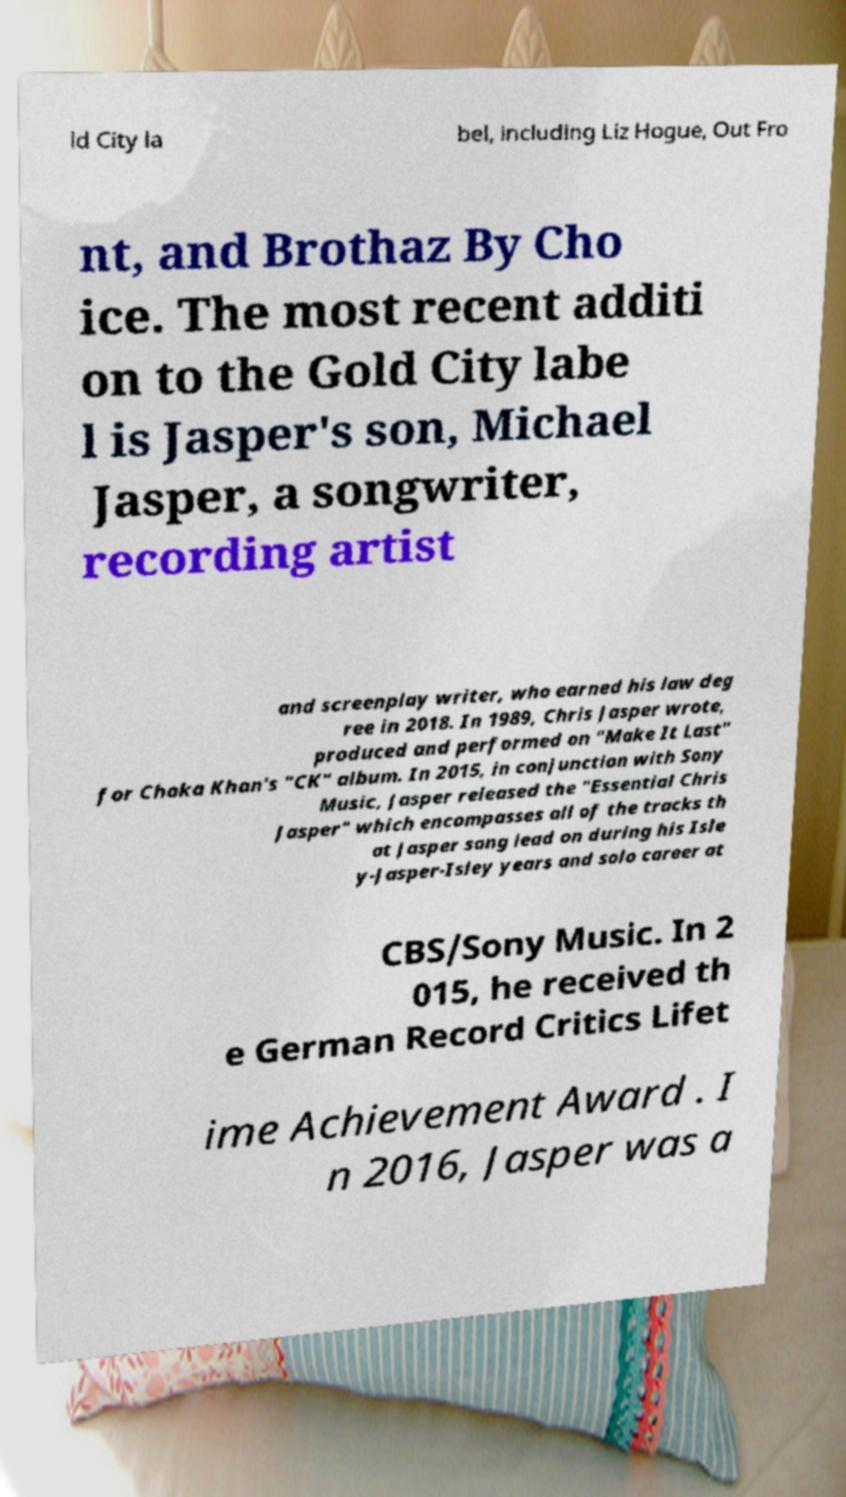Can you read and provide the text displayed in the image?This photo seems to have some interesting text. Can you extract and type it out for me? ld City la bel, including Liz Hogue, Out Fro nt, and Brothaz By Cho ice. The most recent additi on to the Gold City labe l is Jasper's son, Michael Jasper, a songwriter, recording artist and screenplay writer, who earned his law deg ree in 2018. In 1989, Chris Jasper wrote, produced and performed on "Make It Last" for Chaka Khan's "CK" album. In 2015, in conjunction with Sony Music, Jasper released the "Essential Chris Jasper" which encompasses all of the tracks th at Jasper sang lead on during his Isle y-Jasper-Isley years and solo career at CBS/Sony Music. In 2 015, he received th e German Record Critics Lifet ime Achievement Award . I n 2016, Jasper was a 